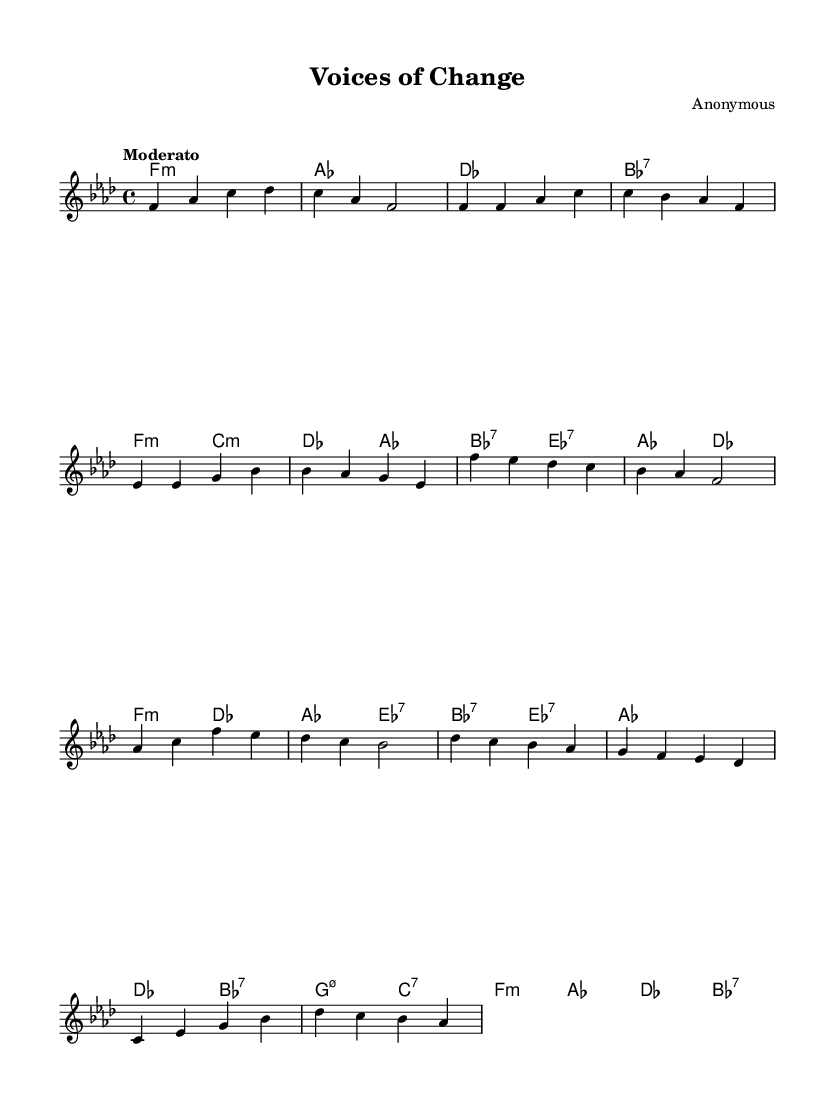What is the key signature of this music? The key signature is based on the global settings defined at the beginning of the code, which specifies the key as F minor. This is indicated by the presence of four flats in the key signature.
Answer: F minor What is the time signature of this piece? The time signature is stated clearly in the global settings, where it specifies a 4/4 time. This means there are four beats per measure, and a quarter note gets one beat.
Answer: 4/4 What is the tempo marking of this piece? The tempo marking is included in the global settings. It is marked as "Moderato," suggesting a moderate pace of performance.
Answer: Moderato How many measures are in the intro section? By analyzing the music, the intro section consists of one complete measure which spans from the first to the fourth beat.
Answer: 1 What is the first chord played in the introduction? To determine this, we look at the harmonies section where the first chord is labeled as "f1:m," indicating it is an F minor chord.
Answer: F minor What type of chord is the last chord in the bridge section? The last chord in the bridge as indicated in the harmonies section is "des bes:7," where "bes:7" refers to a B flat seven chord.
Answer: B flat seven How many lines are in the melody section of the score? The melody section is written on a standard five-line staff, which is typical for most music notation. Therefore, it has five lines.
Answer: 5 